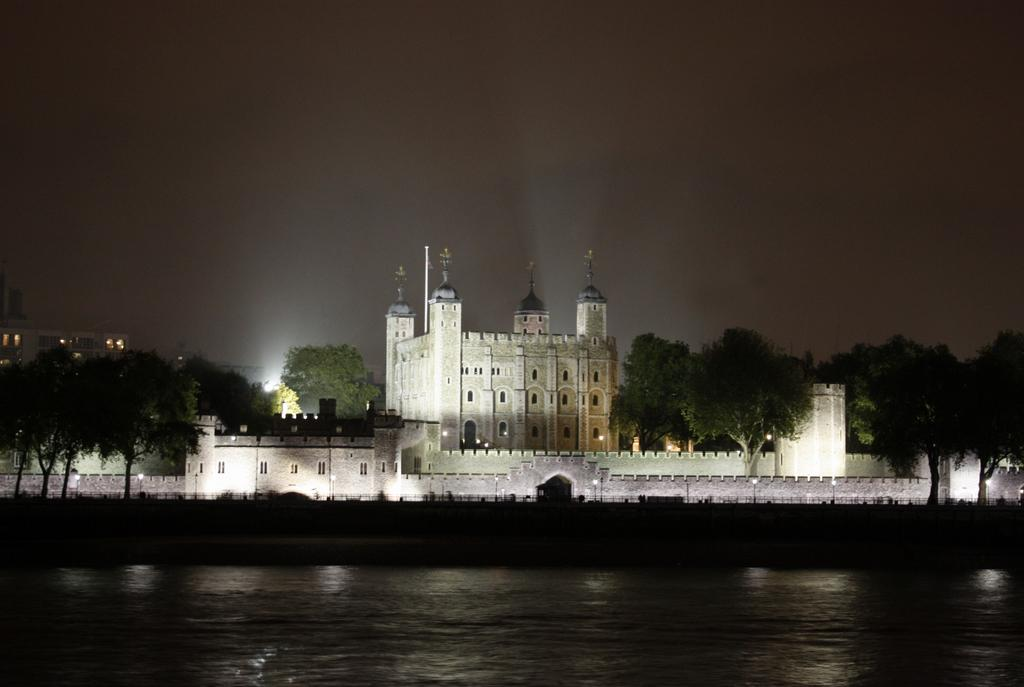What is the primary element visible in the image? There is water in the image. What type of structure can be seen in the image? There is a fence in the image. What type of man-made structures are present in the image? There are buildings in the image. What type of illumination is present in the image? There are lights in the image. What type of natural elements can be seen in the image? There are trees in the image. What part of the natural environment is visible in the image? The sky is visible in the image. What is the name of the lumber that is being used to build the buildings in the image? There is no lumber visible in the image, and the buildings' construction materials are not specified. 